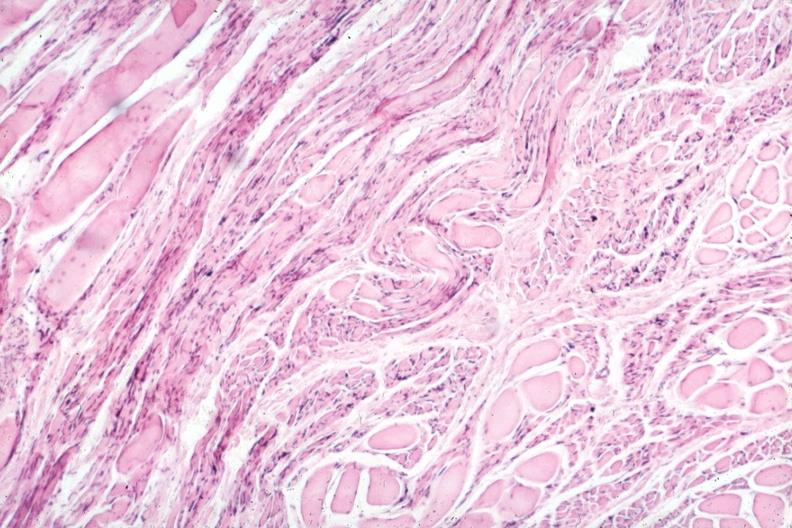what is present?
Answer the question using a single word or phrase. Muscle 